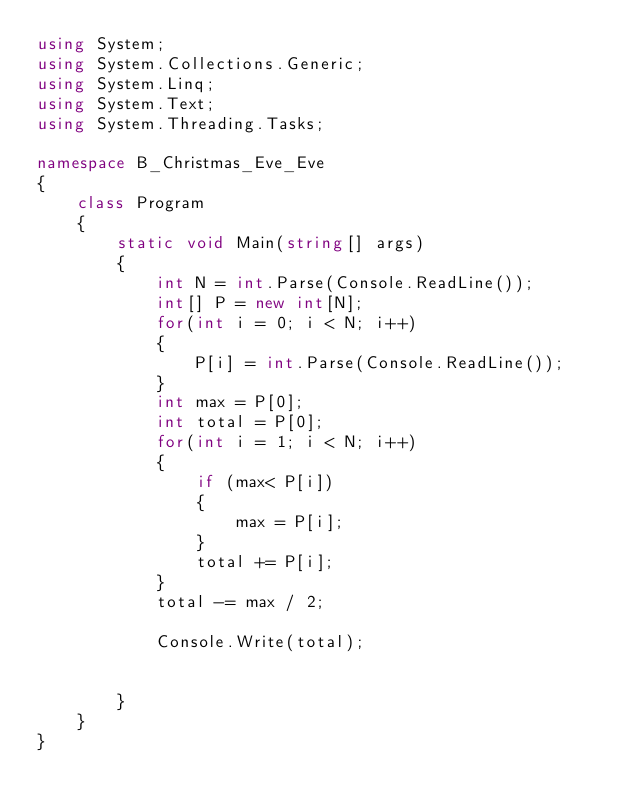<code> <loc_0><loc_0><loc_500><loc_500><_C#_>using System;
using System.Collections.Generic;
using System.Linq;
using System.Text;
using System.Threading.Tasks;

namespace B_Christmas_Eve_Eve
{
    class Program
    {
        static void Main(string[] args)
        {
            int N = int.Parse(Console.ReadLine());
            int[] P = new int[N];
            for(int i = 0; i < N; i++)
            {
                P[i] = int.Parse(Console.ReadLine());
            }
            int max = P[0];
            int total = P[0];
            for(int i = 1; i < N; i++)
            {
                if (max< P[i])
                {
                    max = P[i];
                }
                total += P[i];
            }
            total -= max / 2;

            Console.Write(total);
          
           
        }
    }
}</code> 